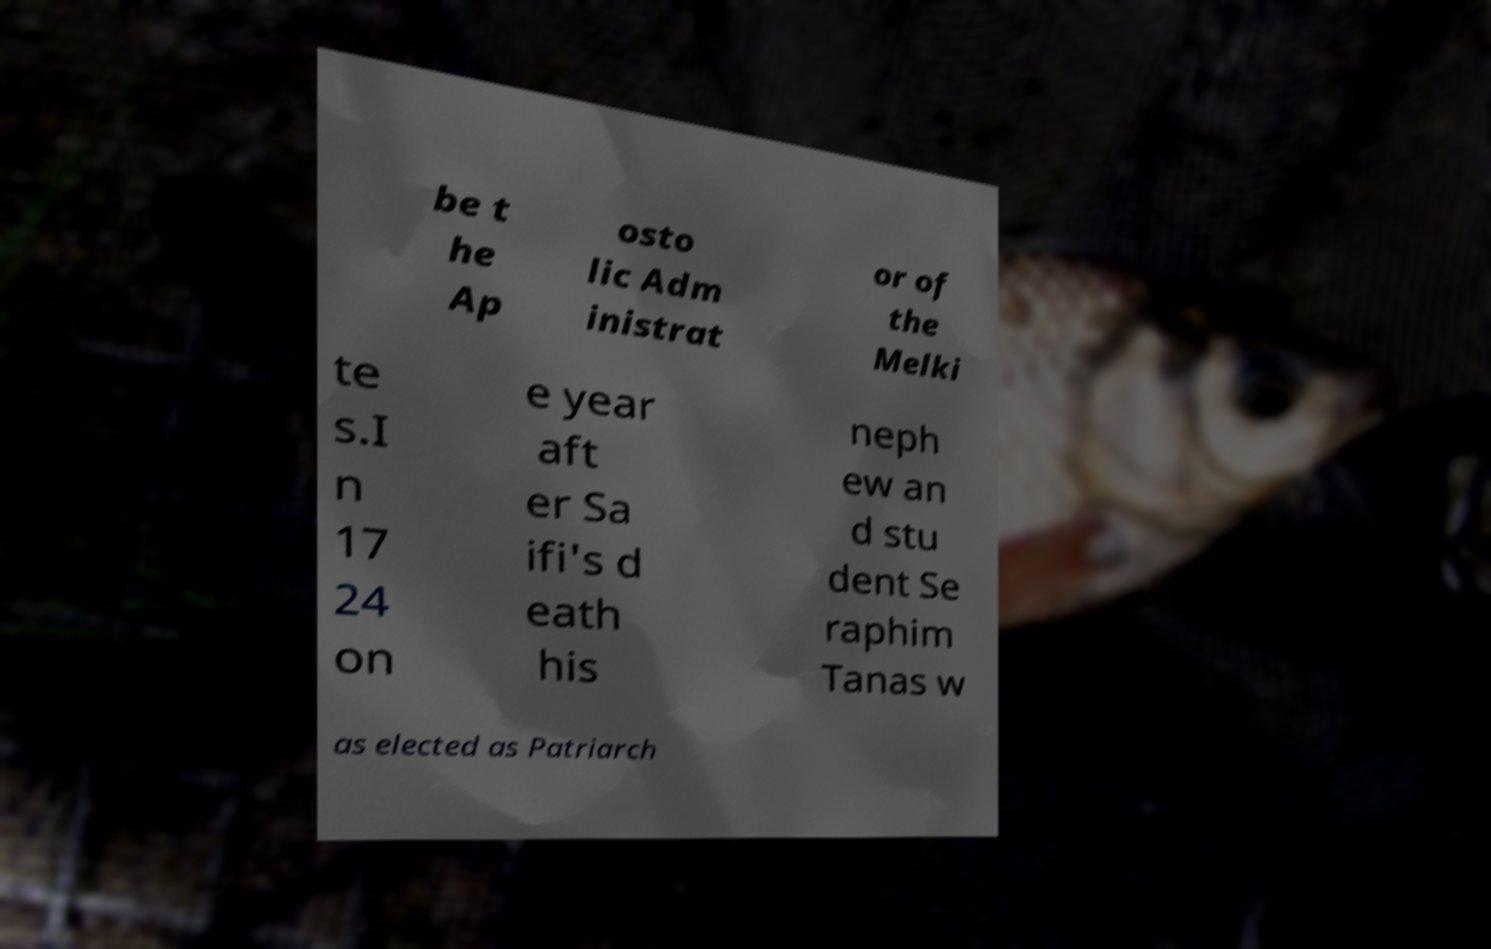I need the written content from this picture converted into text. Can you do that? be t he Ap osto lic Adm inistrat or of the Melki te s.I n 17 24 on e year aft er Sa ifi's d eath his neph ew an d stu dent Se raphim Tanas w as elected as Patriarch 